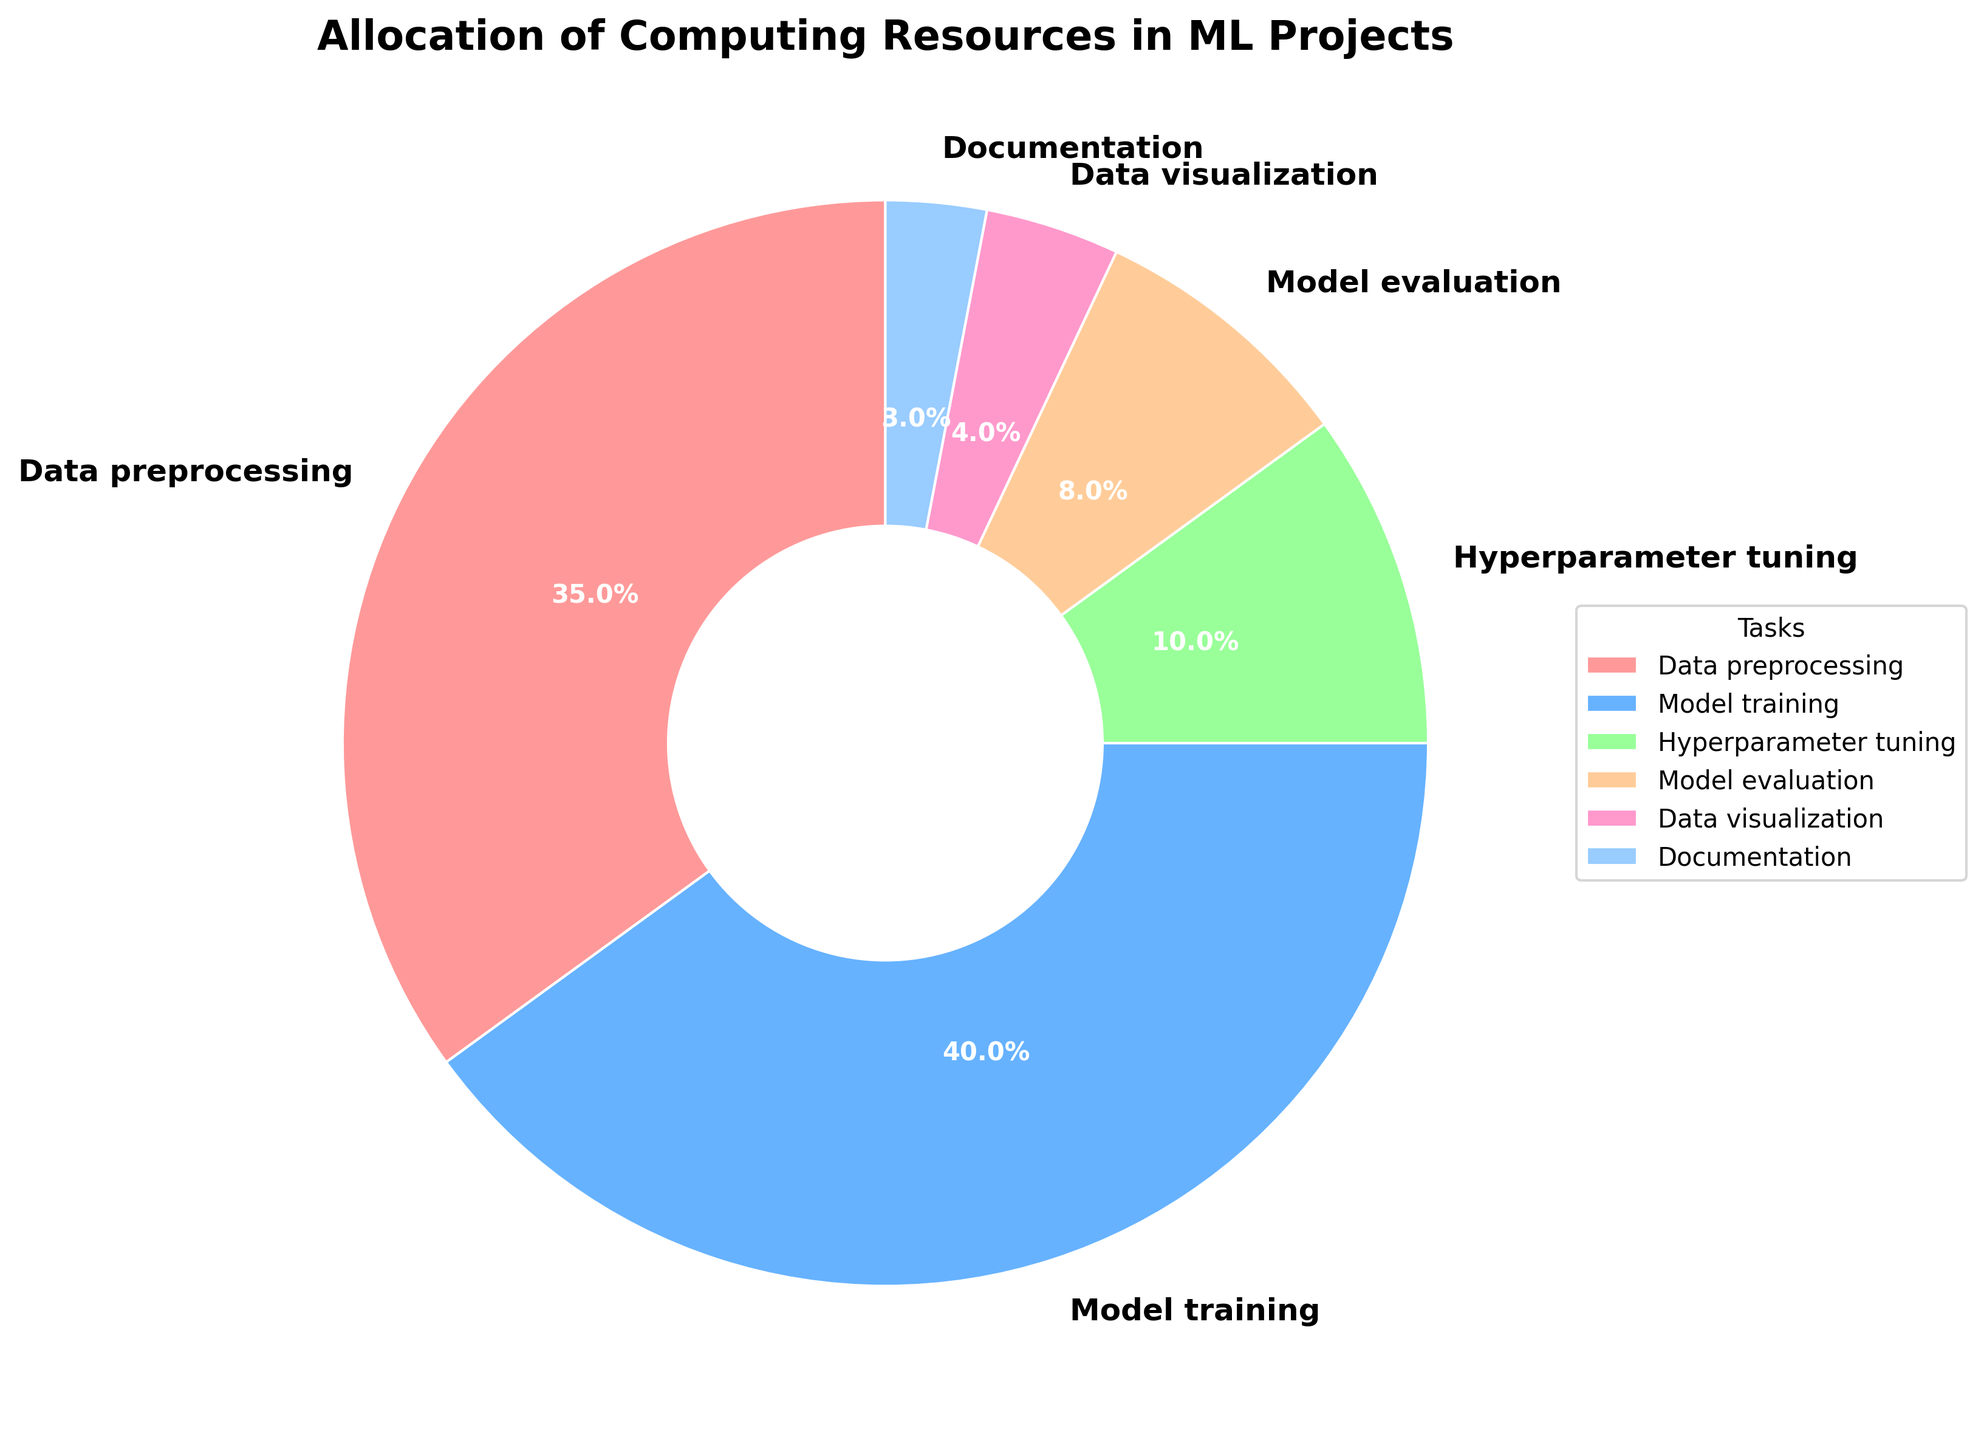What task takes up the largest percentage of computing resources? By observing the size of the wedges and the percentage labels on the pie chart, we can easily see that Model training, with 40%, occupies the largest portion.
Answer: Model training What is the combined percentage of Data preprocessing and Model training? Sum the percentages labeled for Data preprocessing (35%) and Model training (40%). So, 35% + 40% = 75%.
Answer: 75% Which task uses fewer resources, Hyperparameter tuning or Data visualization? By comparing the percentage labels on the pie chart for Hyperparameter tuning (10%) and Data visualization (4%), we see that Data visualization uses fewer resources.
Answer: Data visualization How much more percentage of resources is allocated to Model evaluation than Documentation? Subtract the percentage of Documentation (3%) from the percentage of Model evaluation (8%). So, 8% - 3% = 5%.
Answer: 5% What is the percentage difference between the task with the most resources and the task with the least resources? The task with the most resources is Model training at 40%, and the task with the least is Documentation at 3%. Subtract 3% from 40%, resulting in 37%.
Answer: 37% Which task has a portion colored in a shade of red? By referring to the given colors in the pie chart, the wedge colored in a shade of red corresponds to Data preprocessing.
Answer: Data preprocessing How do the resources allocated to Data visualization compare to those allocated to Hyperparameter tuning? Comparing the percentages on the pie chart, Data visualization (4%) has fewer resources allocated than Hyperparameter tuning (10%).
Answer: Data visualization has fewer If you combine the resources for Data preprocessing, Data visualization, and Documentation, how does the combined percentage compare to the resources for Model training alone? Add the percentages of Data preprocessing (35%), Data visualization (4%), and Documentation (3%) to get 42%. Then compare it to Model training (40%). 42% is greater than 40%.
Answer: 42% is greater Which task occupies the smallest portion of the pie chart? By identifying the smallest wedge in the pie chart, we can see that Documentation, at 3%, occupies the smallest portion.
Answer: Documentation 